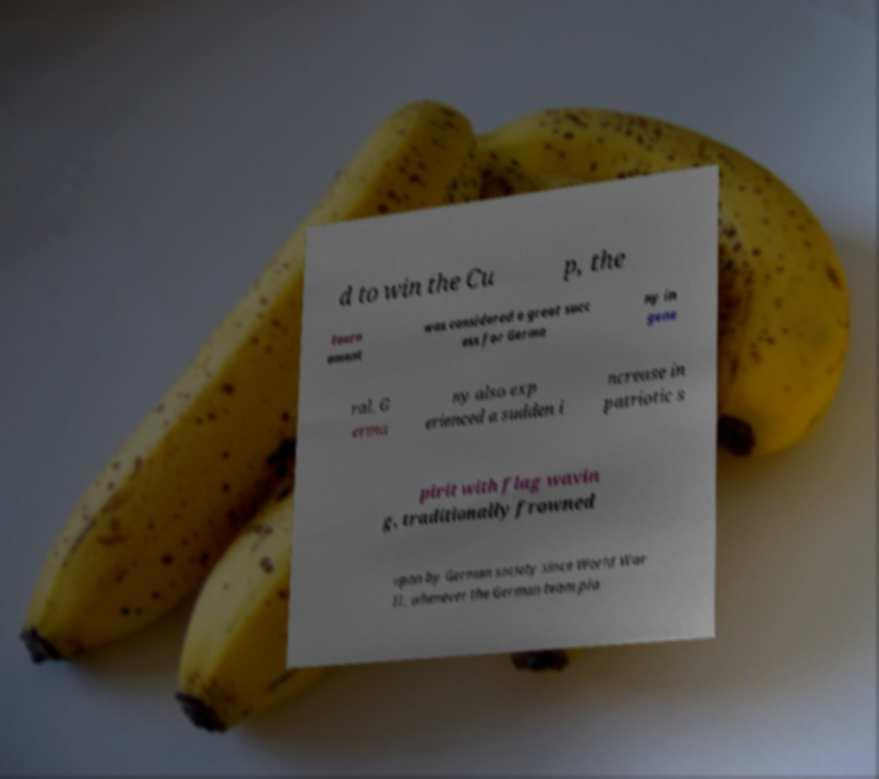I need the written content from this picture converted into text. Can you do that? d to win the Cu p, the tourn ament was considered a great succ ess for Germa ny in gene ral. G erma ny also exp erienced a sudden i ncrease in patriotic s pirit with flag wavin g, traditionally frowned upon by German society since World War II, whenever the German team pla 